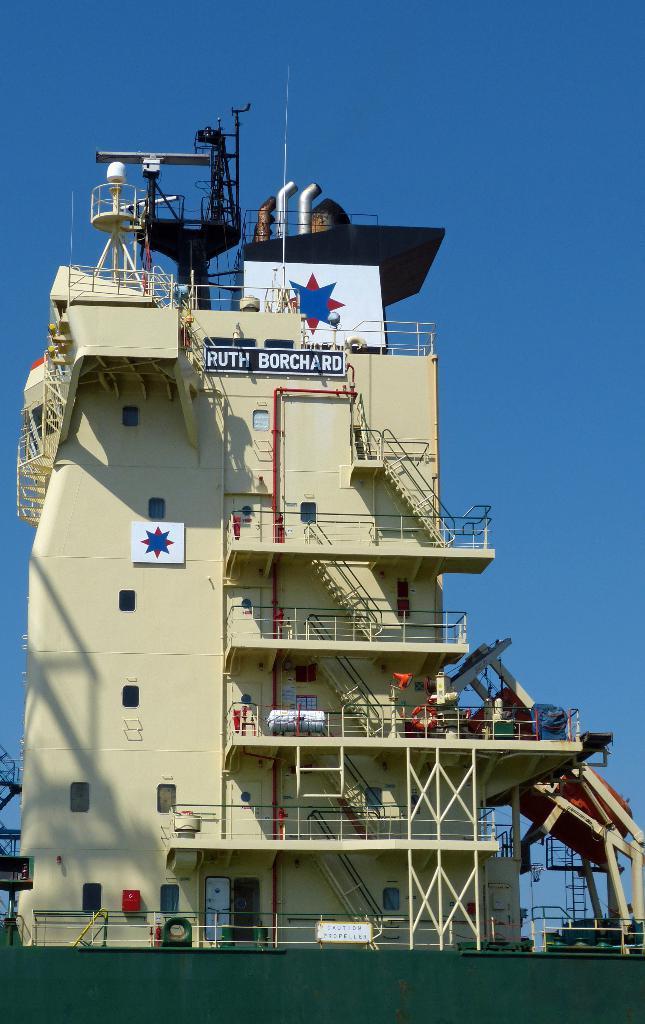In one or two sentences, can you explain what this image depicts? In the picture I can see industrial building which has pipes, windows and metal staircase and top of the picture there is clear sky. 